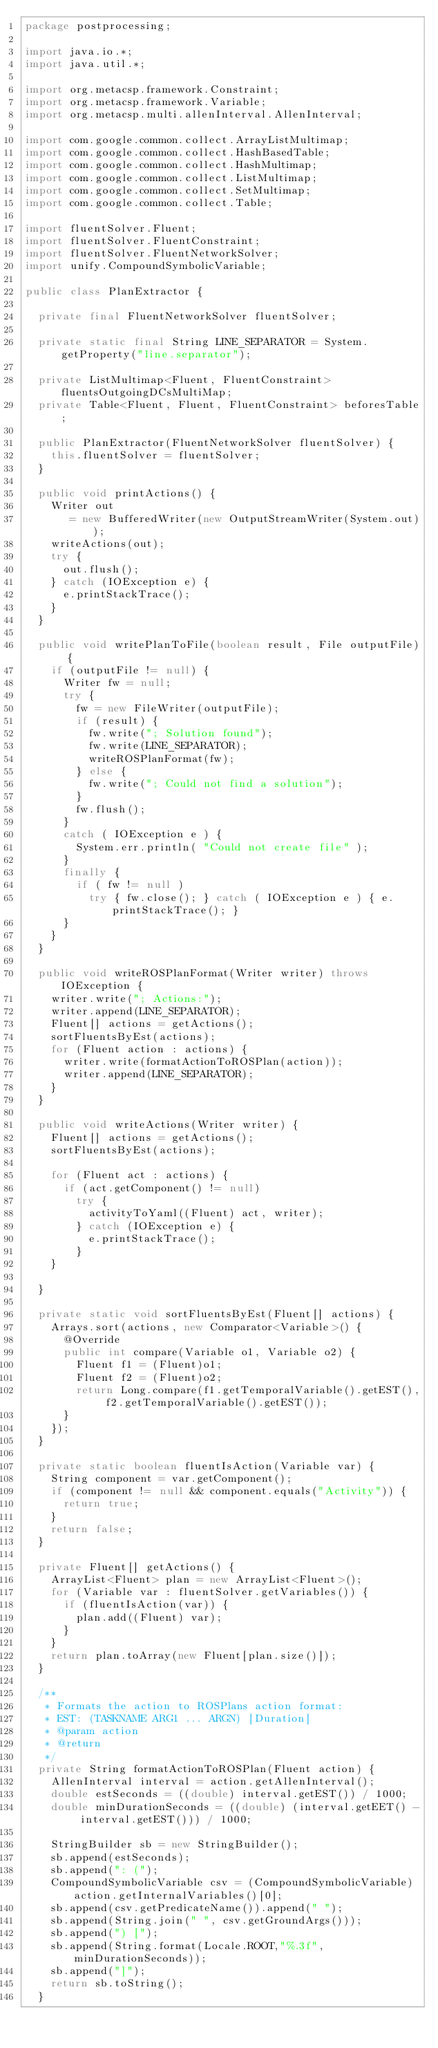Convert code to text. <code><loc_0><loc_0><loc_500><loc_500><_Java_>package postprocessing;

import java.io.*;
import java.util.*;

import org.metacsp.framework.Constraint;
import org.metacsp.framework.Variable;
import org.metacsp.multi.allenInterval.AllenInterval;

import com.google.common.collect.ArrayListMultimap;
import com.google.common.collect.HashBasedTable;
import com.google.common.collect.HashMultimap;
import com.google.common.collect.ListMultimap;
import com.google.common.collect.SetMultimap;
import com.google.common.collect.Table;

import fluentSolver.Fluent;
import fluentSolver.FluentConstraint;
import fluentSolver.FluentNetworkSolver;
import unify.CompoundSymbolicVariable;

public class PlanExtractor {
	
	private final FluentNetworkSolver fluentSolver;
	
	private static final String LINE_SEPARATOR = System.getProperty("line.separator");
	
	private ListMultimap<Fluent, FluentConstraint> fluentsOutgoingDCsMultiMap;
	private Table<Fluent, Fluent, FluentConstraint> beforesTable;

	public PlanExtractor(FluentNetworkSolver fluentSolver) {
		this.fluentSolver = fluentSolver;
	}

	public void printActions() {
		Writer out
		   = new BufferedWriter(new OutputStreamWriter(System.out));
		writeActions(out);
		try {
			out.flush();
		} catch (IOException e) {
			e.printStackTrace();
		}
	}

	public void writePlanToFile(boolean result, File outputFile) {
		if (outputFile != null) {
			Writer fw = null;
			try {
				fw = new FileWriter(outputFile);
				if (result) {
					fw.write("; Solution found");
					fw.write(LINE_SEPARATOR);
					writeROSPlanFormat(fw);
				} else {
					fw.write("; Could not find a solution");
				}
				fw.flush();
			}
			catch ( IOException e ) {
				System.err.println( "Could not create file" );
			}
			finally {
				if ( fw != null )
					try { fw.close(); } catch ( IOException e ) { e.printStackTrace(); }
			}
		}
	}

	public void writeROSPlanFormat(Writer writer) throws IOException {
		writer.write("; Actions:");
		writer.append(LINE_SEPARATOR);
		Fluent[] actions = getActions();
		sortFluentsByEst(actions);
		for (Fluent action : actions) {
			writer.write(formatActionToROSPlan(action));
			writer.append(LINE_SEPARATOR);
		}
	}

	public void writeActions(Writer writer) {
		Fluent[] actions = getActions();
		sortFluentsByEst(actions);

		for (Fluent act : actions) {
			if (act.getComponent() != null)
				try {
					activityToYaml((Fluent) act, writer);
				} catch (IOException e) {
					e.printStackTrace();
				}
		}

	}

	private static void sortFluentsByEst(Fluent[] actions) {
		Arrays.sort(actions, new Comparator<Variable>() {
			@Override
			public int compare(Variable o1, Variable o2) {
				Fluent f1 = (Fluent)o1;
				Fluent f2 = (Fluent)o2;
				return Long.compare(f1.getTemporalVariable().getEST(), f2.getTemporalVariable().getEST());
			}
		});
	}

	private static boolean fluentIsAction(Variable var) {
		String component = var.getComponent();
		if (component != null && component.equals("Activity")) {
			return true;
		}
		return false;
	}

	private Fluent[] getActions() {
		ArrayList<Fluent> plan = new ArrayList<Fluent>();
		for (Variable var : fluentSolver.getVariables()) {
			if (fluentIsAction(var)) {
				plan.add((Fluent) var);
			}
		}
		return plan.toArray(new Fluent[plan.size()]);
	}

	/**
	 * Formats the action to ROSPlans action format:
	 * EST: (TASKNAME ARG1 ... ARGN) [Duration]
	 * @param action
	 * @return
	 */
	private String formatActionToROSPlan(Fluent action) {
		AllenInterval interval = action.getAllenInterval();
		double estSeconds = ((double) interval.getEST()) / 1000;
		double minDurationSeconds = ((double) (interval.getEET() - interval.getEST())) / 1000;

		StringBuilder sb = new StringBuilder();
		sb.append(estSeconds);
		sb.append(": (");
		CompoundSymbolicVariable csv = (CompoundSymbolicVariable) action.getInternalVariables()[0];
		sb.append(csv.getPredicateName()).append(" ");
		sb.append(String.join(" ", csv.getGroundArgs()));
		sb.append(") [");
		sb.append(String.format(Locale.ROOT,"%.3f", minDurationSeconds));
		sb.append("]");
		return sb.toString();
	}
</code> 